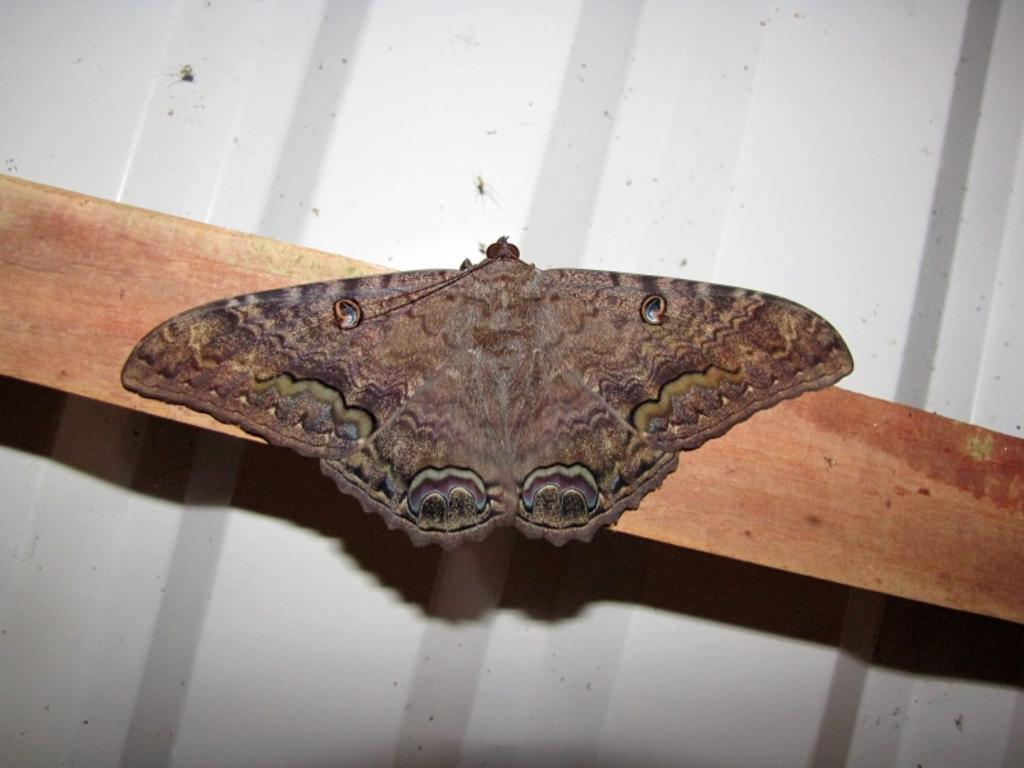What is the main subject of the image? There is a butterfly in the image. Where is the butterfly located? The butterfly is on wood. What can be seen in the background of the image? There is a sheet in the background of the image. What type of offer is the butterfly making on the branch in the image? There is no branch present in the image, and the butterfly is not making any offers. 